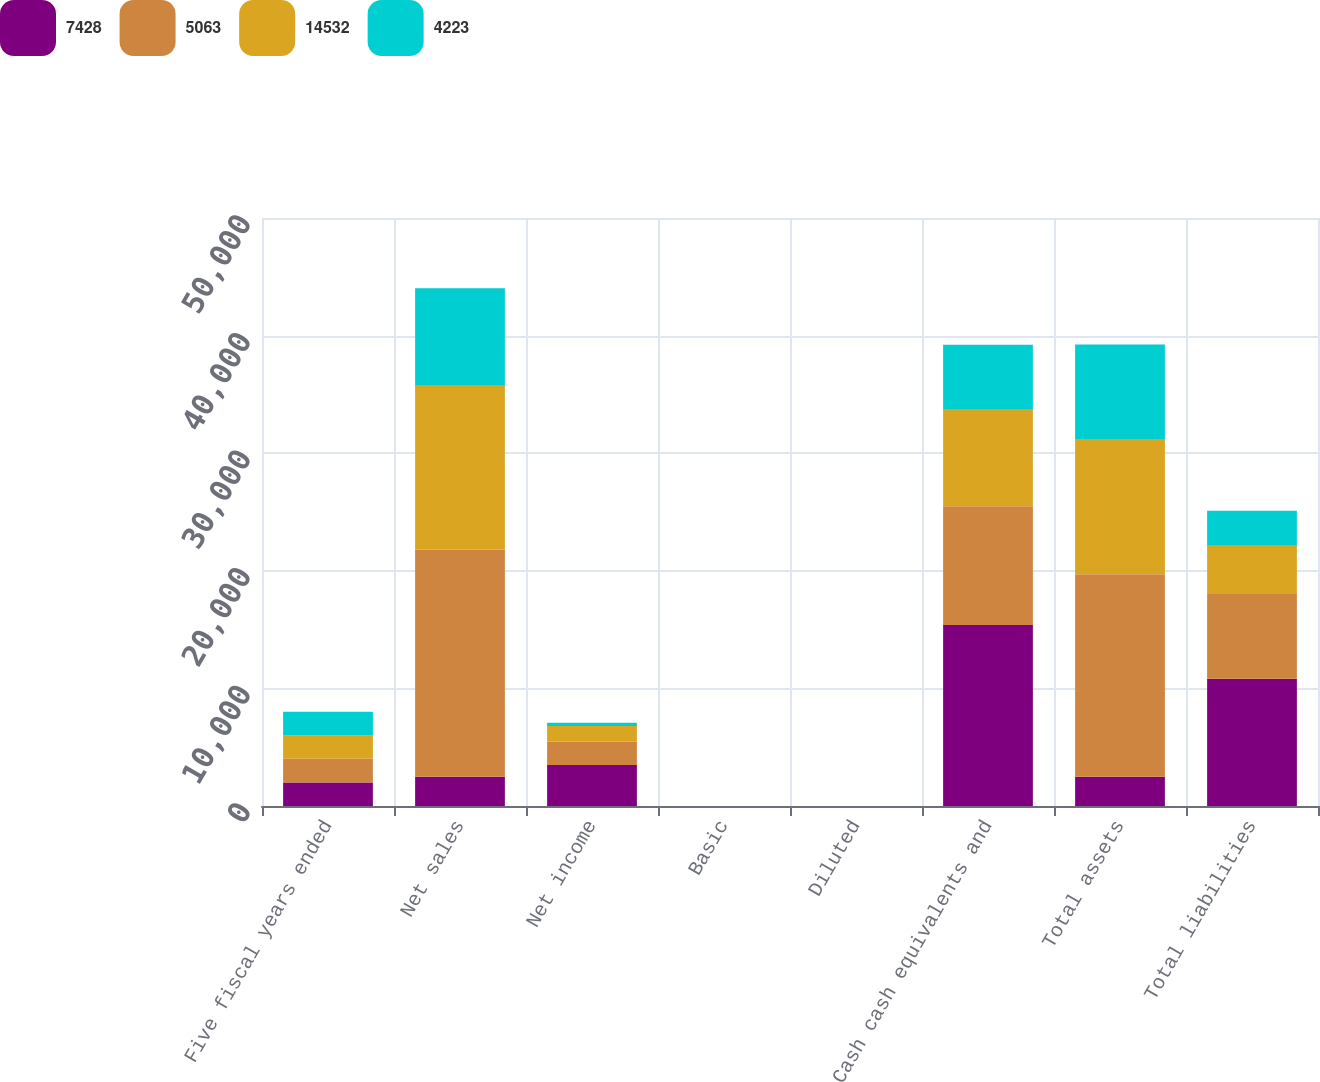<chart> <loc_0><loc_0><loc_500><loc_500><stacked_bar_chart><ecel><fcel>Five fiscal years ended<fcel>Net sales<fcel>Net income<fcel>Basic<fcel>Diluted<fcel>Cash cash equivalents and<fcel>Total assets<fcel>Total liabilities<nl><fcel>7428<fcel>2007<fcel>2491.5<fcel>3496<fcel>4.04<fcel>3.93<fcel>15386<fcel>2491.5<fcel>10815<nl><fcel>5063<fcel>2006<fcel>19315<fcel>1989<fcel>2.36<fcel>2.27<fcel>10110<fcel>17205<fcel>7221<nl><fcel>14532<fcel>2005<fcel>13931<fcel>1328<fcel>1.64<fcel>1.55<fcel>8261<fcel>11516<fcel>4088<nl><fcel>4223<fcel>2004<fcel>8279<fcel>266<fcel>0.36<fcel>0.34<fcel>5464<fcel>8039<fcel>2976<nl></chart> 